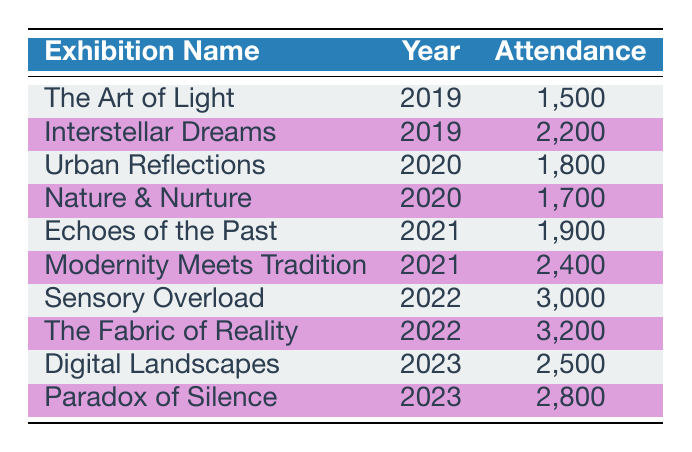What was the attendance at "Sensory Overload"? The attendance for "Sensory Overload" is listed in the table under the corresponding row, showing that it had an attendance of 3,000.
Answer: 3000 Which exhibition had the highest attendance in 2022? Looking at the year 2022 in the table, "The Fabric of Reality" has the highest attendance with 3,200.
Answer: 3200 How many visitors attended art exhibitions in 2020? To find the total attendance for 2020, add the attendances for "Urban Reflections" (1,800) and "Nature & Nurture" (1,700). This equals 1,800 + 1,700 = 3,500 total attendees for 2020.
Answer: 3500 Did "Interstellar Dreams" have more attendees than "Echoes of the Past"? By comparing the attendance figures in the table, "Interstellar Dreams" has 2,200 while "Echoes of the Past" has 1,900, confirming that "Interstellar Dreams" had more attendees.
Answer: Yes What is the average attendance of exhibitions in 2021? The two exhibitions in 2021 are "Echoes of the Past" (1,900) and "Modernity Meets Tradition" (2,400). Adding these together gives 1,900 + 2,400 = 4,300. To find the average, divide by 2, which gives 4,300 / 2 = 2,150.
Answer: 2150 Which exhibition had the lowest attendance overall? A close inspection of all attendance numbers reveals that "The Art of Light" had the lowest attendance with 1,500.
Answer: 1500 Between 2019 and 2023, how many exhibitions had an attendance of over 2,500? From the table, the exhibitions with attendance over 2,500 are "Sensory Overload" (3,000), "The Fabric of Reality" (3,200), "Digital Landscapes" (2,500), and "Paradox of Silence" (2,800). This amounts to a total of 4 exhibitions with attendances over 2,500.
Answer: 4 Was there a year where the total attendance was higher than in 2022? By calculating the total attendance for each year: for 2019 (1,500 + 2,200 = 3,700), for 2020 (3,500), for 2021 (4,300), and for 2023 (2,500 + 2,800 = 5,300). The attendance in 2021 (4,300) and 2023 (5,300) was higher than in 2022 (6,200), confirming there were years with higher attendance, specifically 2023.
Answer: Yes What was the total attendance across all exhibitions? Summing all attendance numbers: 1,500 + 2,200 + 1,800 + 1,700 + 1,900 + 2,400 + 3,000 + 3,200 + 2,500 + 2,800, which equals 24,000 total attendees across all exhibitions.
Answer: 24000 